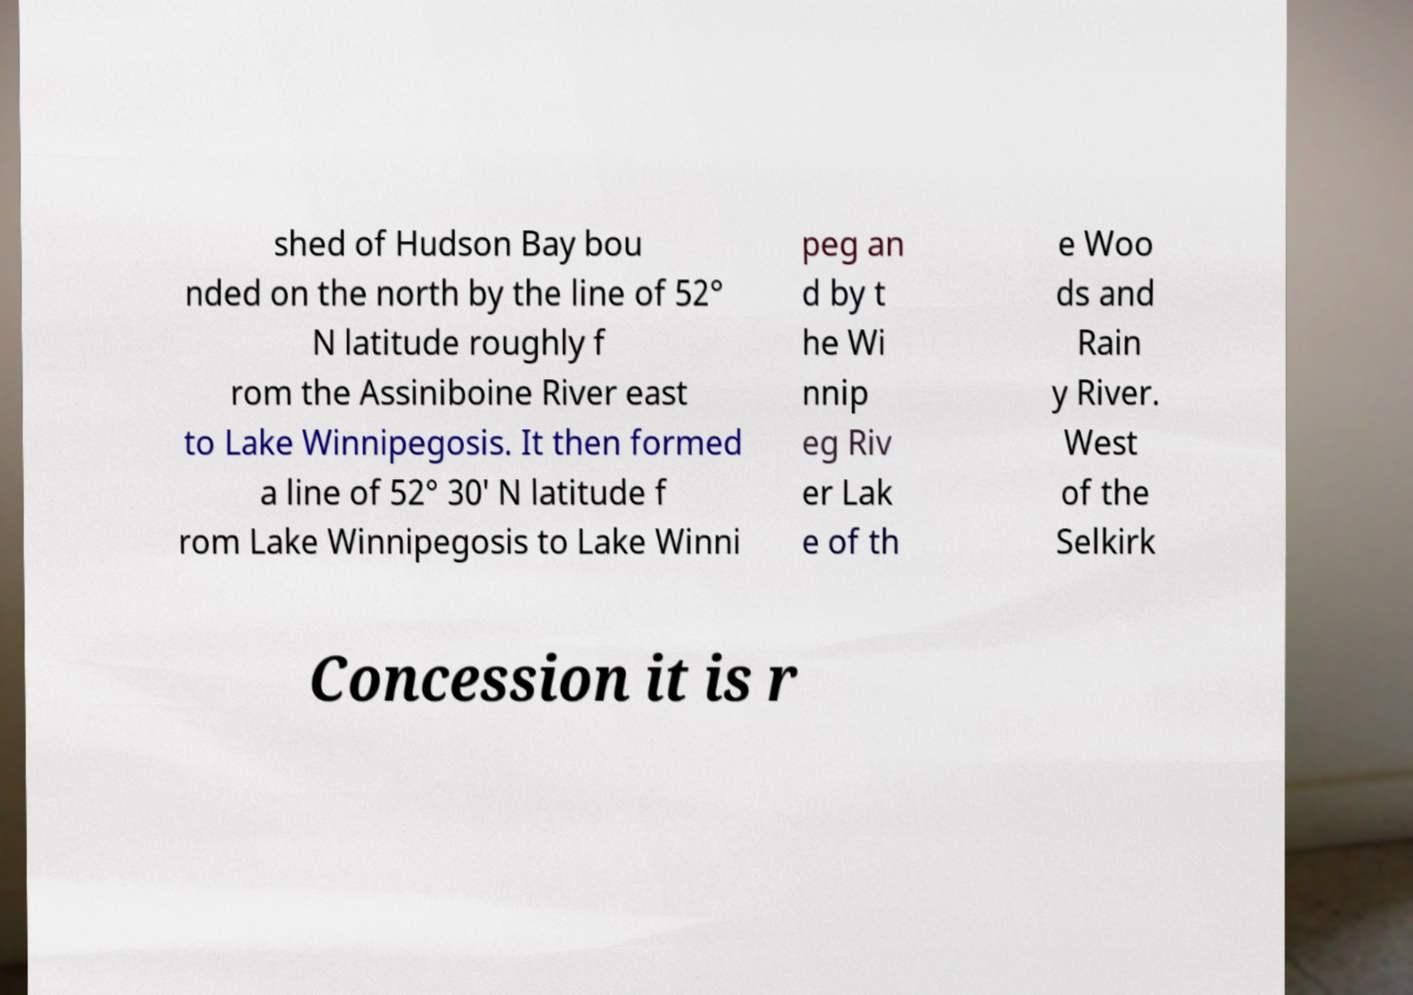For documentation purposes, I need the text within this image transcribed. Could you provide that? shed of Hudson Bay bou nded on the north by the line of 52° N latitude roughly f rom the Assiniboine River east to Lake Winnipegosis. It then formed a line of 52° 30′ N latitude f rom Lake Winnipegosis to Lake Winni peg an d by t he Wi nnip eg Riv er Lak e of th e Woo ds and Rain y River. West of the Selkirk Concession it is r 